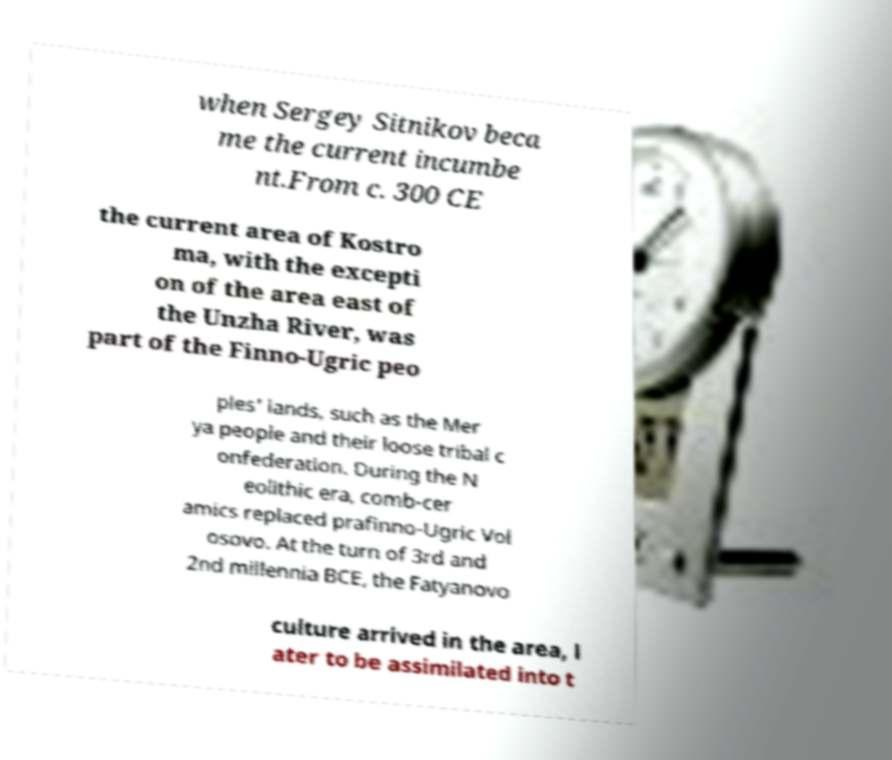Could you extract and type out the text from this image? when Sergey Sitnikov beca me the current incumbe nt.From c. 300 CE the current area of Kostro ma, with the excepti on of the area east of the Unzha River, was part of the Finno-Ugric peo ples' lands, such as the Mer ya people and their loose tribal c onfederation. During the N eolithic era, comb-cer amics replaced prafinno-Ugric Vol osovo. At the turn of 3rd and 2nd millennia BCE, the Fatyanovo culture arrived in the area, l ater to be assimilated into t 